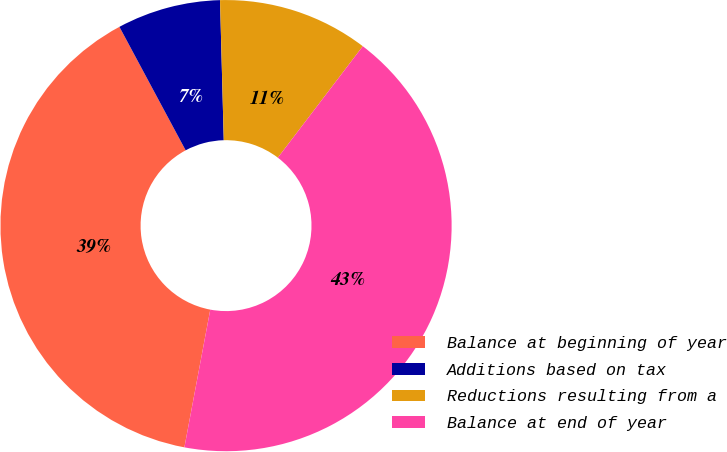Convert chart to OTSL. <chart><loc_0><loc_0><loc_500><loc_500><pie_chart><fcel>Balance at beginning of year<fcel>Additions based on tax<fcel>Reductions resulting from a<fcel>Balance at end of year<nl><fcel>39.21%<fcel>7.41%<fcel>10.79%<fcel>42.59%<nl></chart> 